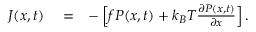Convert formula to latex. <formula><loc_0><loc_0><loc_500><loc_500>\begin{array} { r l r } { J ( x , t ) } & = } & { - \left [ f P ( x , t ) + k _ { B } T { \frac { \partial P ( x , t ) } { \partial x } } \right ] . } \end{array}</formula> 